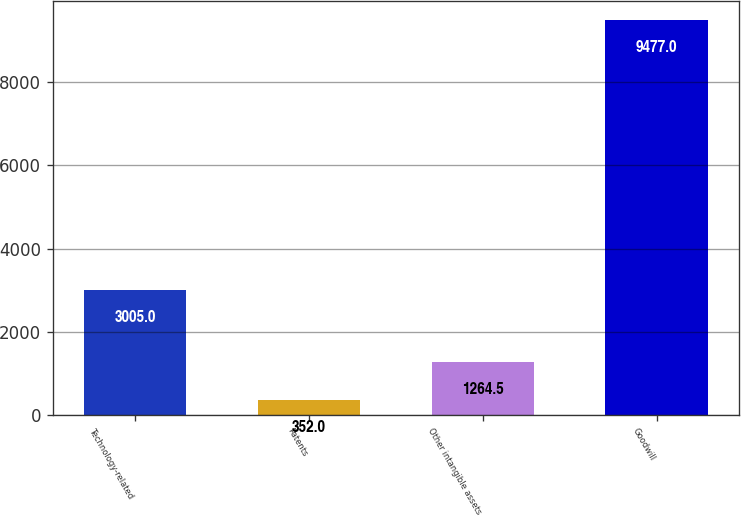Convert chart to OTSL. <chart><loc_0><loc_0><loc_500><loc_500><bar_chart><fcel>Technology-related<fcel>Patents<fcel>Other intangible assets<fcel>Goodwill<nl><fcel>3005<fcel>352<fcel>1264.5<fcel>9477<nl></chart> 